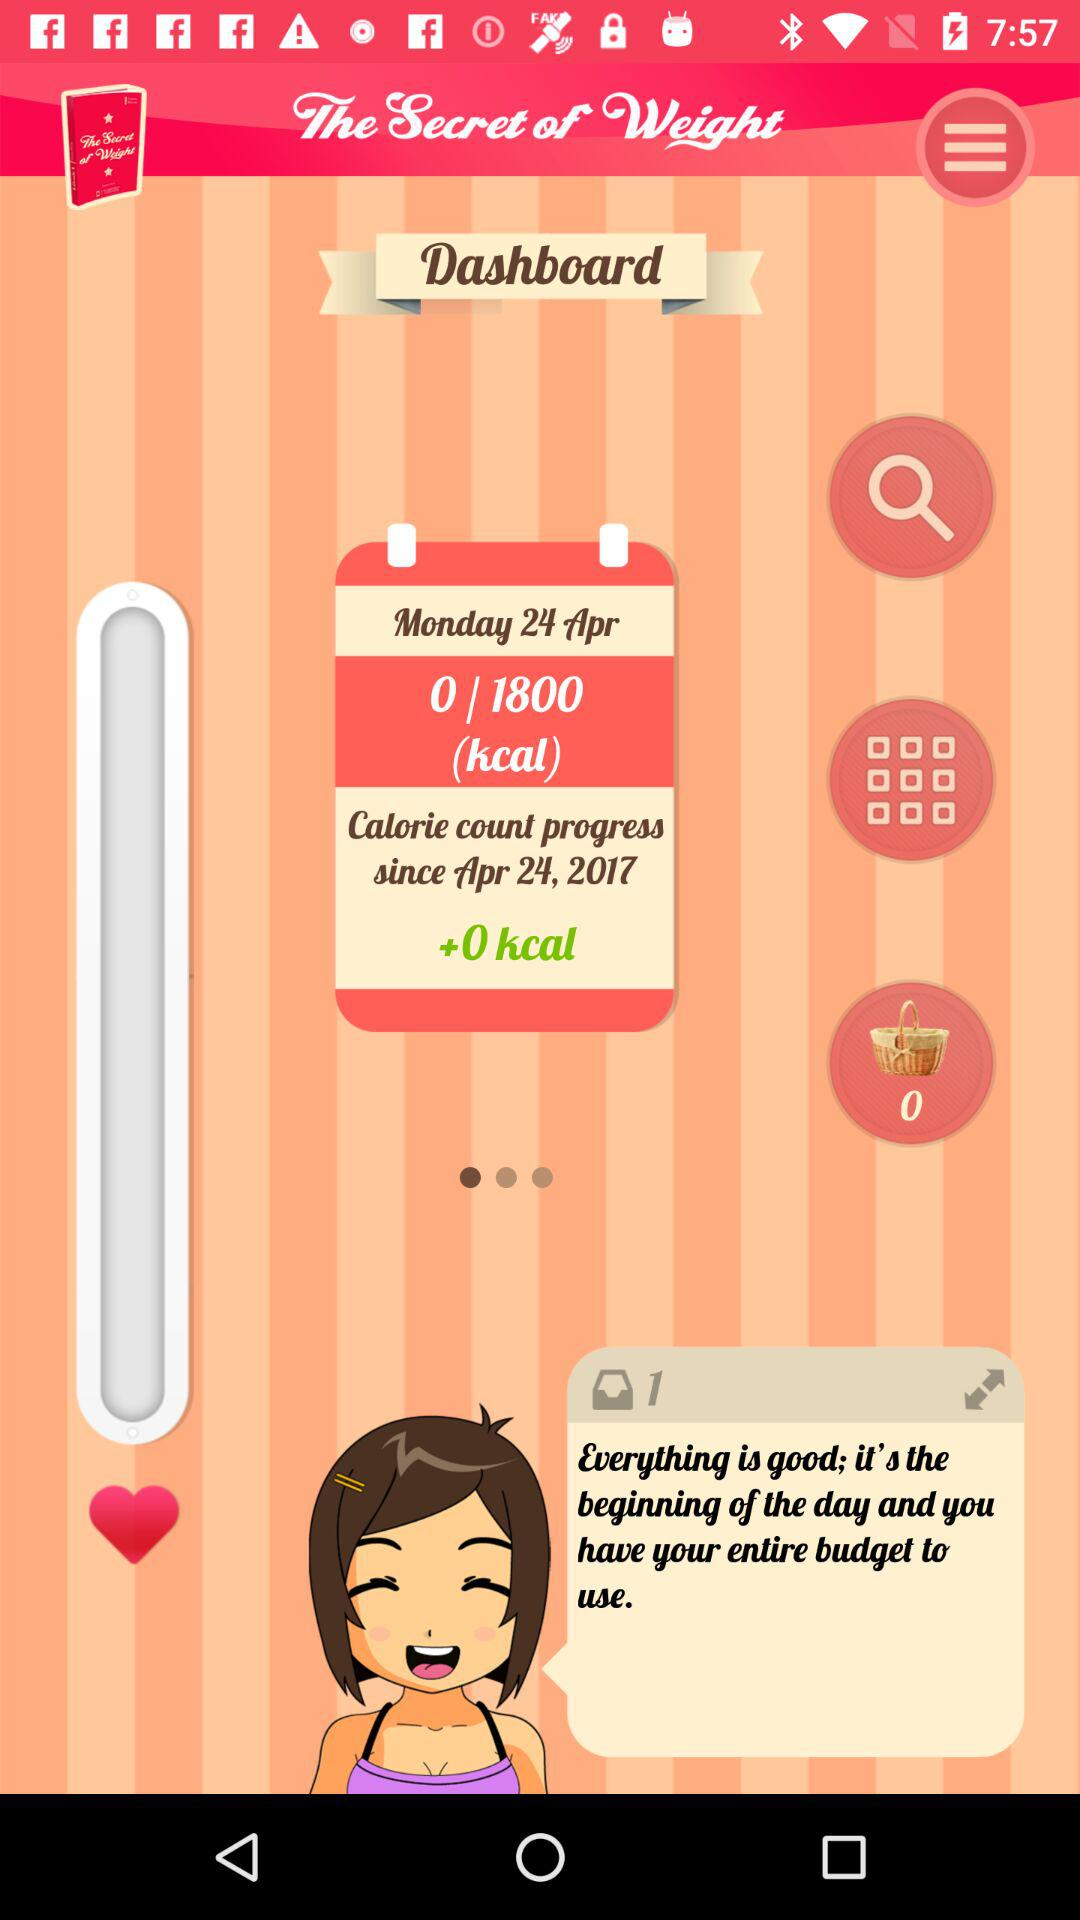How many calories are left to consume today?
Answer the question using a single word or phrase. 1800 